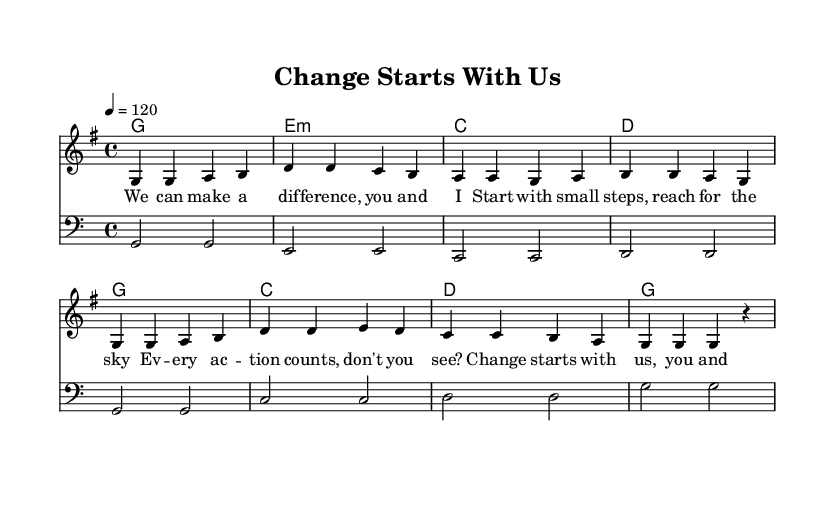What is the key signature of this music? The key signature is G major, which has one sharp (F#). This can be identified typically in the initial part of the sheet music, where the key indication usually appears.
Answer: G major What is the time signature of this music? The time signature is four-four, indicated by the fraction 4/4 at the beginning. This means there are four beats in a measure and the quarter note receives one beat.
Answer: Four-four What is the tempo of this piece? The tempo is marked at 120 beats per minute, indicated by the tempo marking of "4 = 120." This means the quarter note is played at a speed of 120 per minute.
Answer: 120 How many measures are in the melody? The melody consists of eight measures, which can be counted by identifying the vertical bar lines separating sections of the music. Each segment between the bar lines represents one measure.
Answer: Eight measures What is the structure of the lyrical content? The lyrics are structured into a verse format, with four lines that share a consistent rhythm and rhyme scheme. This is visible in the way the lyrics are organized under the melodic line of the music.
Answer: Verse format What chord progression is used in the harmonies? The chord progression follows a sequence of G, E minor, C, D, which can be observed in the chord symbols above the staff. This sequence creates a foundation for the melody and is typical in pop music.
Answer: G, E minor, C, D What is the main message of the song based on the lyrics? The main message conveyed in the lyrics is about making a difference and promoting change through collective action, as inferred from phrases like "Change starts with us, you and me." This reflects a positive and encouraging theme.
Answer: Positive change 